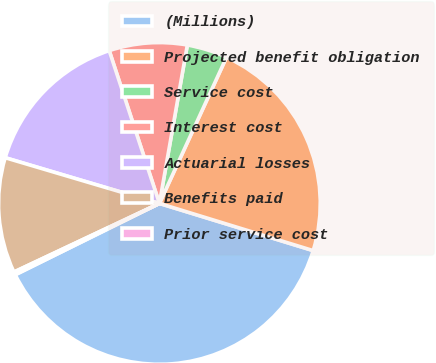Convert chart to OTSL. <chart><loc_0><loc_0><loc_500><loc_500><pie_chart><fcel>(Millions)<fcel>Projected benefit obligation<fcel>Service cost<fcel>Interest cost<fcel>Actuarial losses<fcel>Benefits paid<fcel>Prior service cost<nl><fcel>37.95%<fcel>22.89%<fcel>4.07%<fcel>7.83%<fcel>15.36%<fcel>11.6%<fcel>0.3%<nl></chart> 